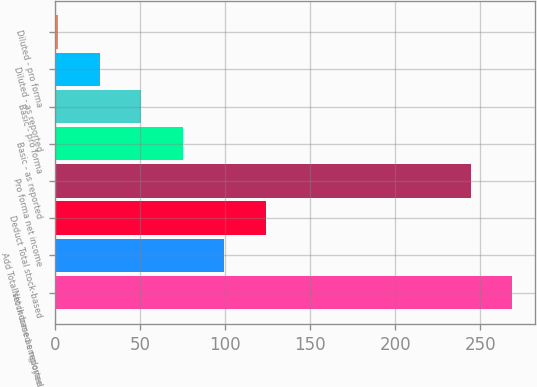Convert chart. <chart><loc_0><loc_0><loc_500><loc_500><bar_chart><fcel>Net income as reported<fcel>Add Total stock-based employee<fcel>Deduct Total stock-based<fcel>Pro forma net income<fcel>Basic - as reported<fcel>Basic - pro forma<fcel>Diluted - as reported<fcel>Diluted - pro forma<nl><fcel>268.97<fcel>99.72<fcel>124.19<fcel>244.5<fcel>75.25<fcel>50.79<fcel>26.32<fcel>1.85<nl></chart> 